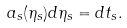Convert formula to latex. <formula><loc_0><loc_0><loc_500><loc_500>a _ { s } ( \eta _ { s } ) d \eta _ { s } = d t _ { s } .</formula> 